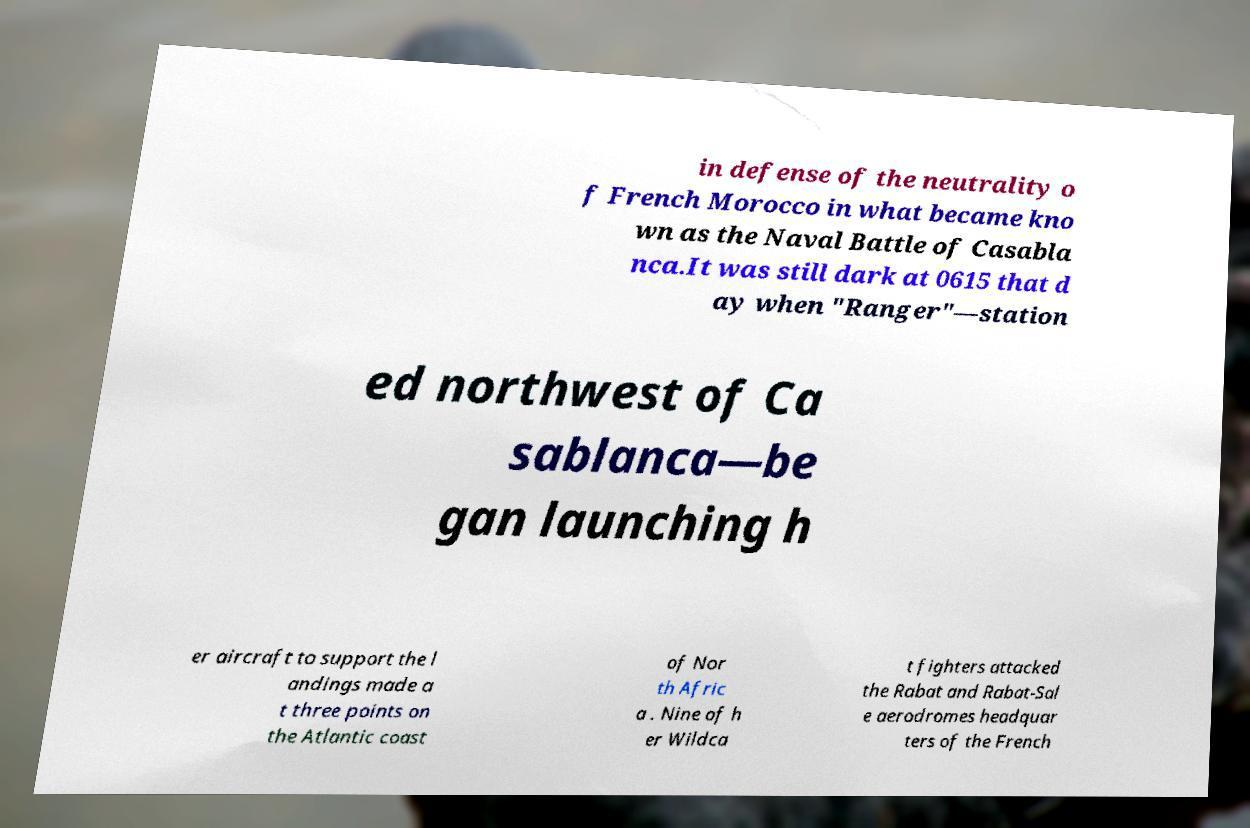Could you extract and type out the text from this image? in defense of the neutrality o f French Morocco in what became kno wn as the Naval Battle of Casabla nca.It was still dark at 0615 that d ay when "Ranger"—station ed northwest of Ca sablanca—be gan launching h er aircraft to support the l andings made a t three points on the Atlantic coast of Nor th Afric a . Nine of h er Wildca t fighters attacked the Rabat and Rabat-Sal e aerodromes headquar ters of the French 